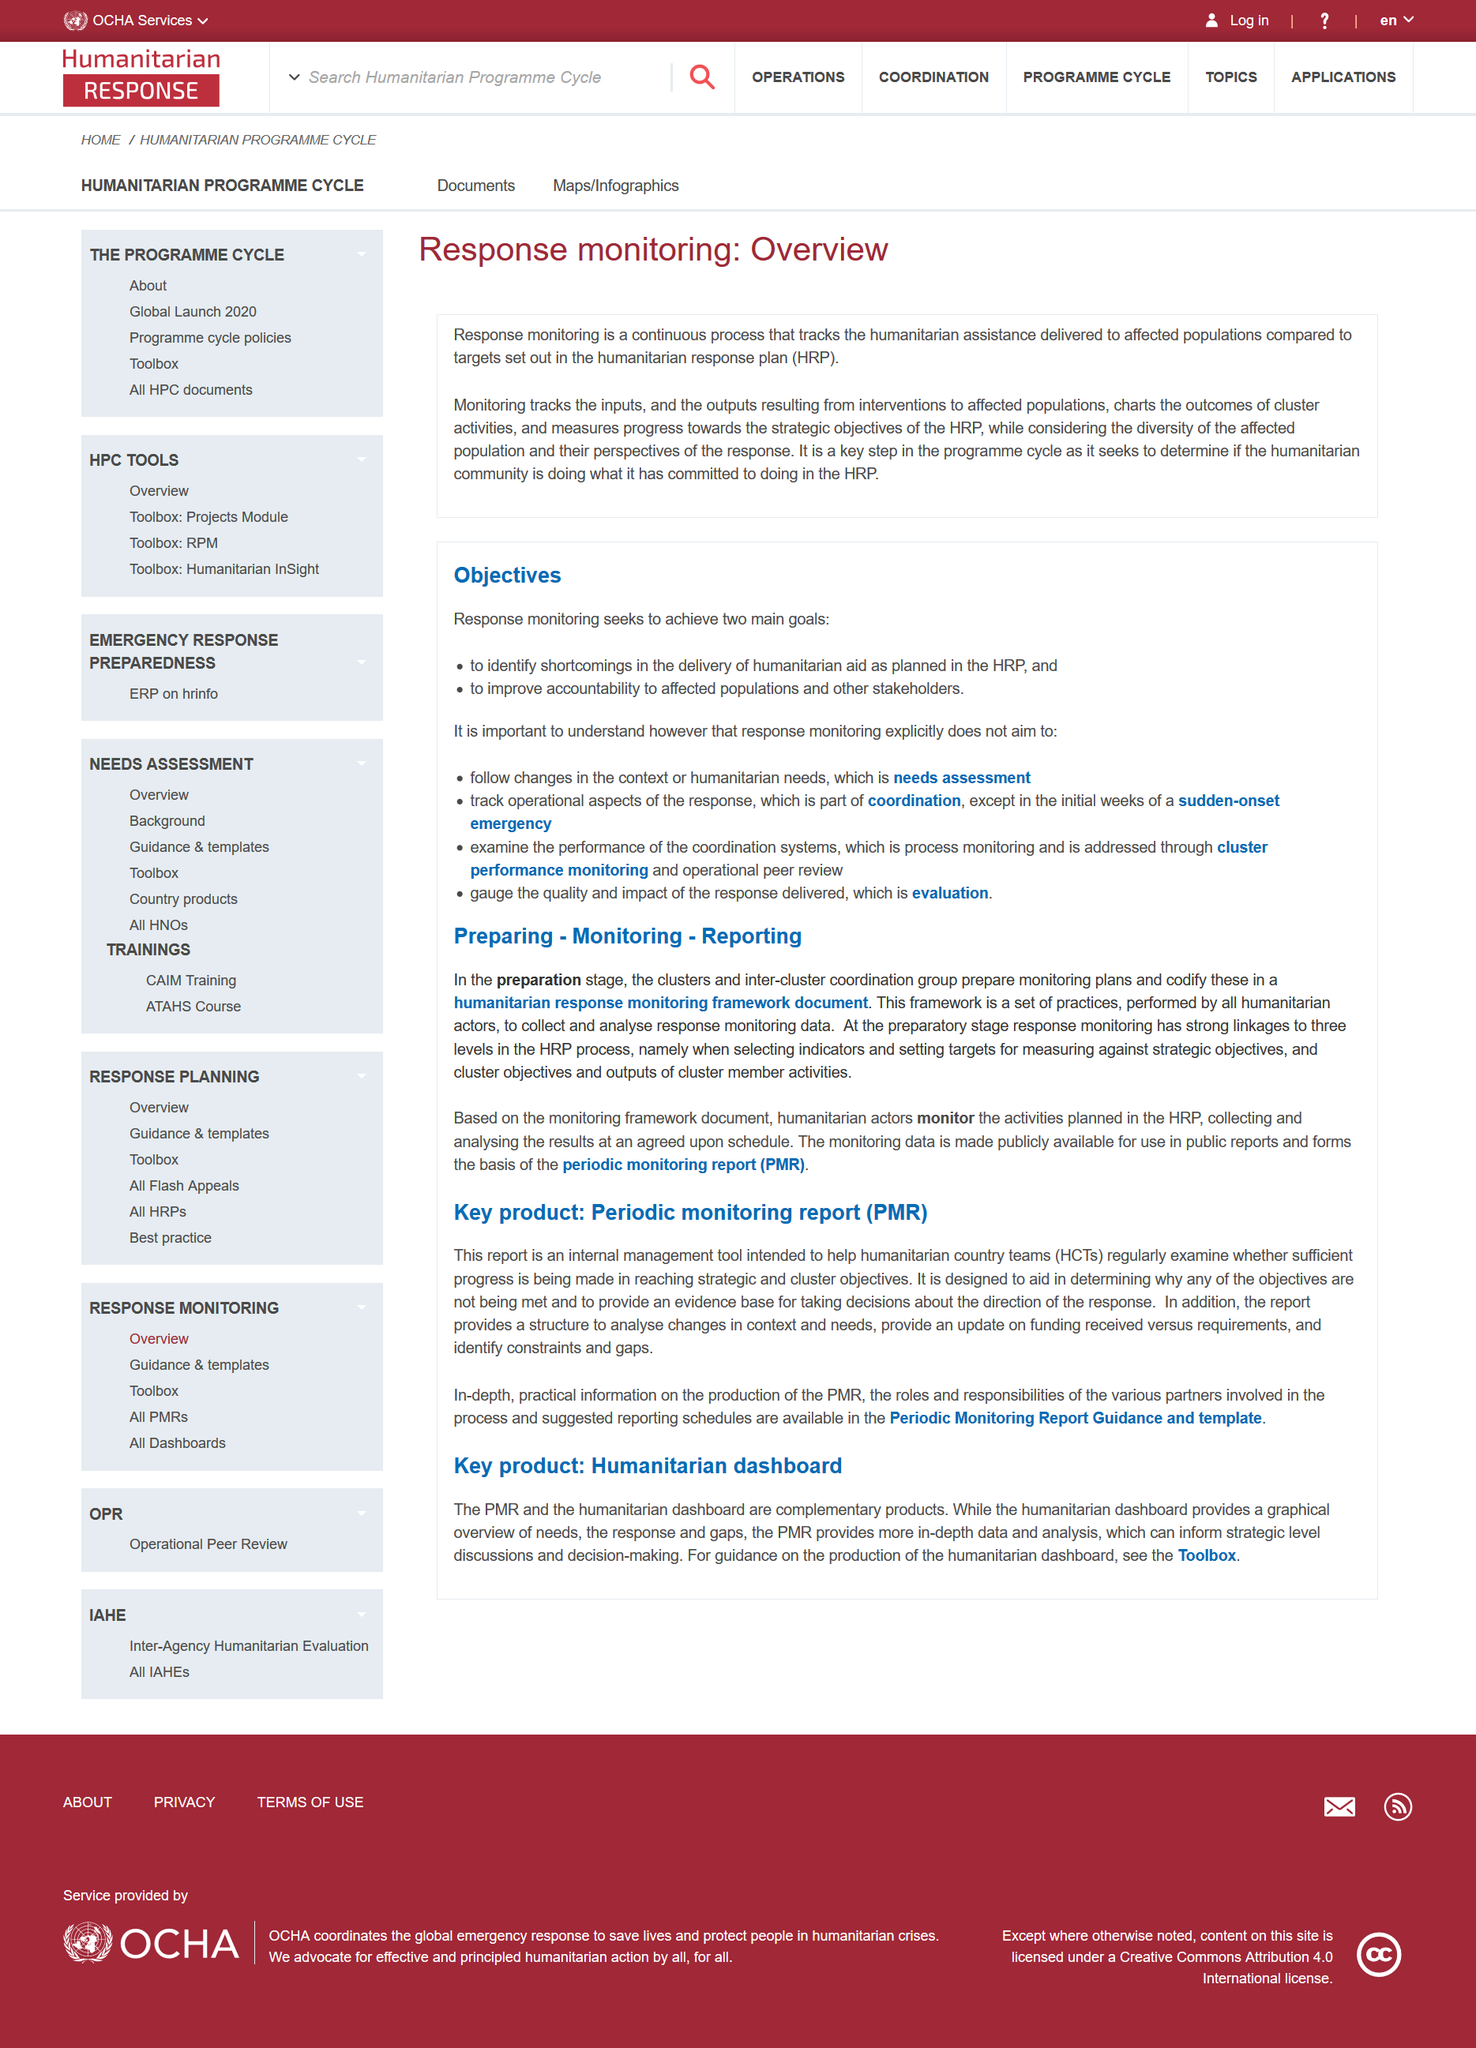Outline some significant characteristics in this image. Response monitoring is a continuous process. Humanitarian Response Plan, commonly known as HRP, is a comprehensive and strategic plan developed to provide humanitarian assistance to those affected by crises and disasters, with a focus on saving lives and reducing suffering. Improving accountability to affected populations and other stakeholders is a key objective of response monitoring. 